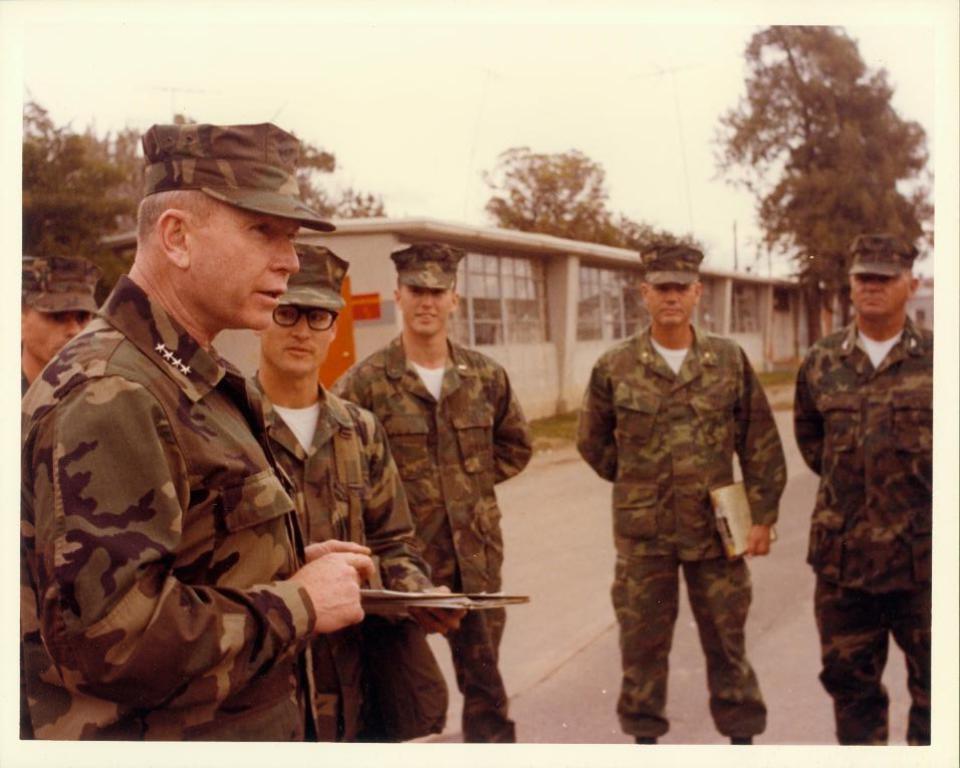Please provide a concise description of this image. In this picture we can see some people standing here, they wore caps, this person is holding a book, in the background there are trees, we can see a house here, there is the sky at the top of the picture. 